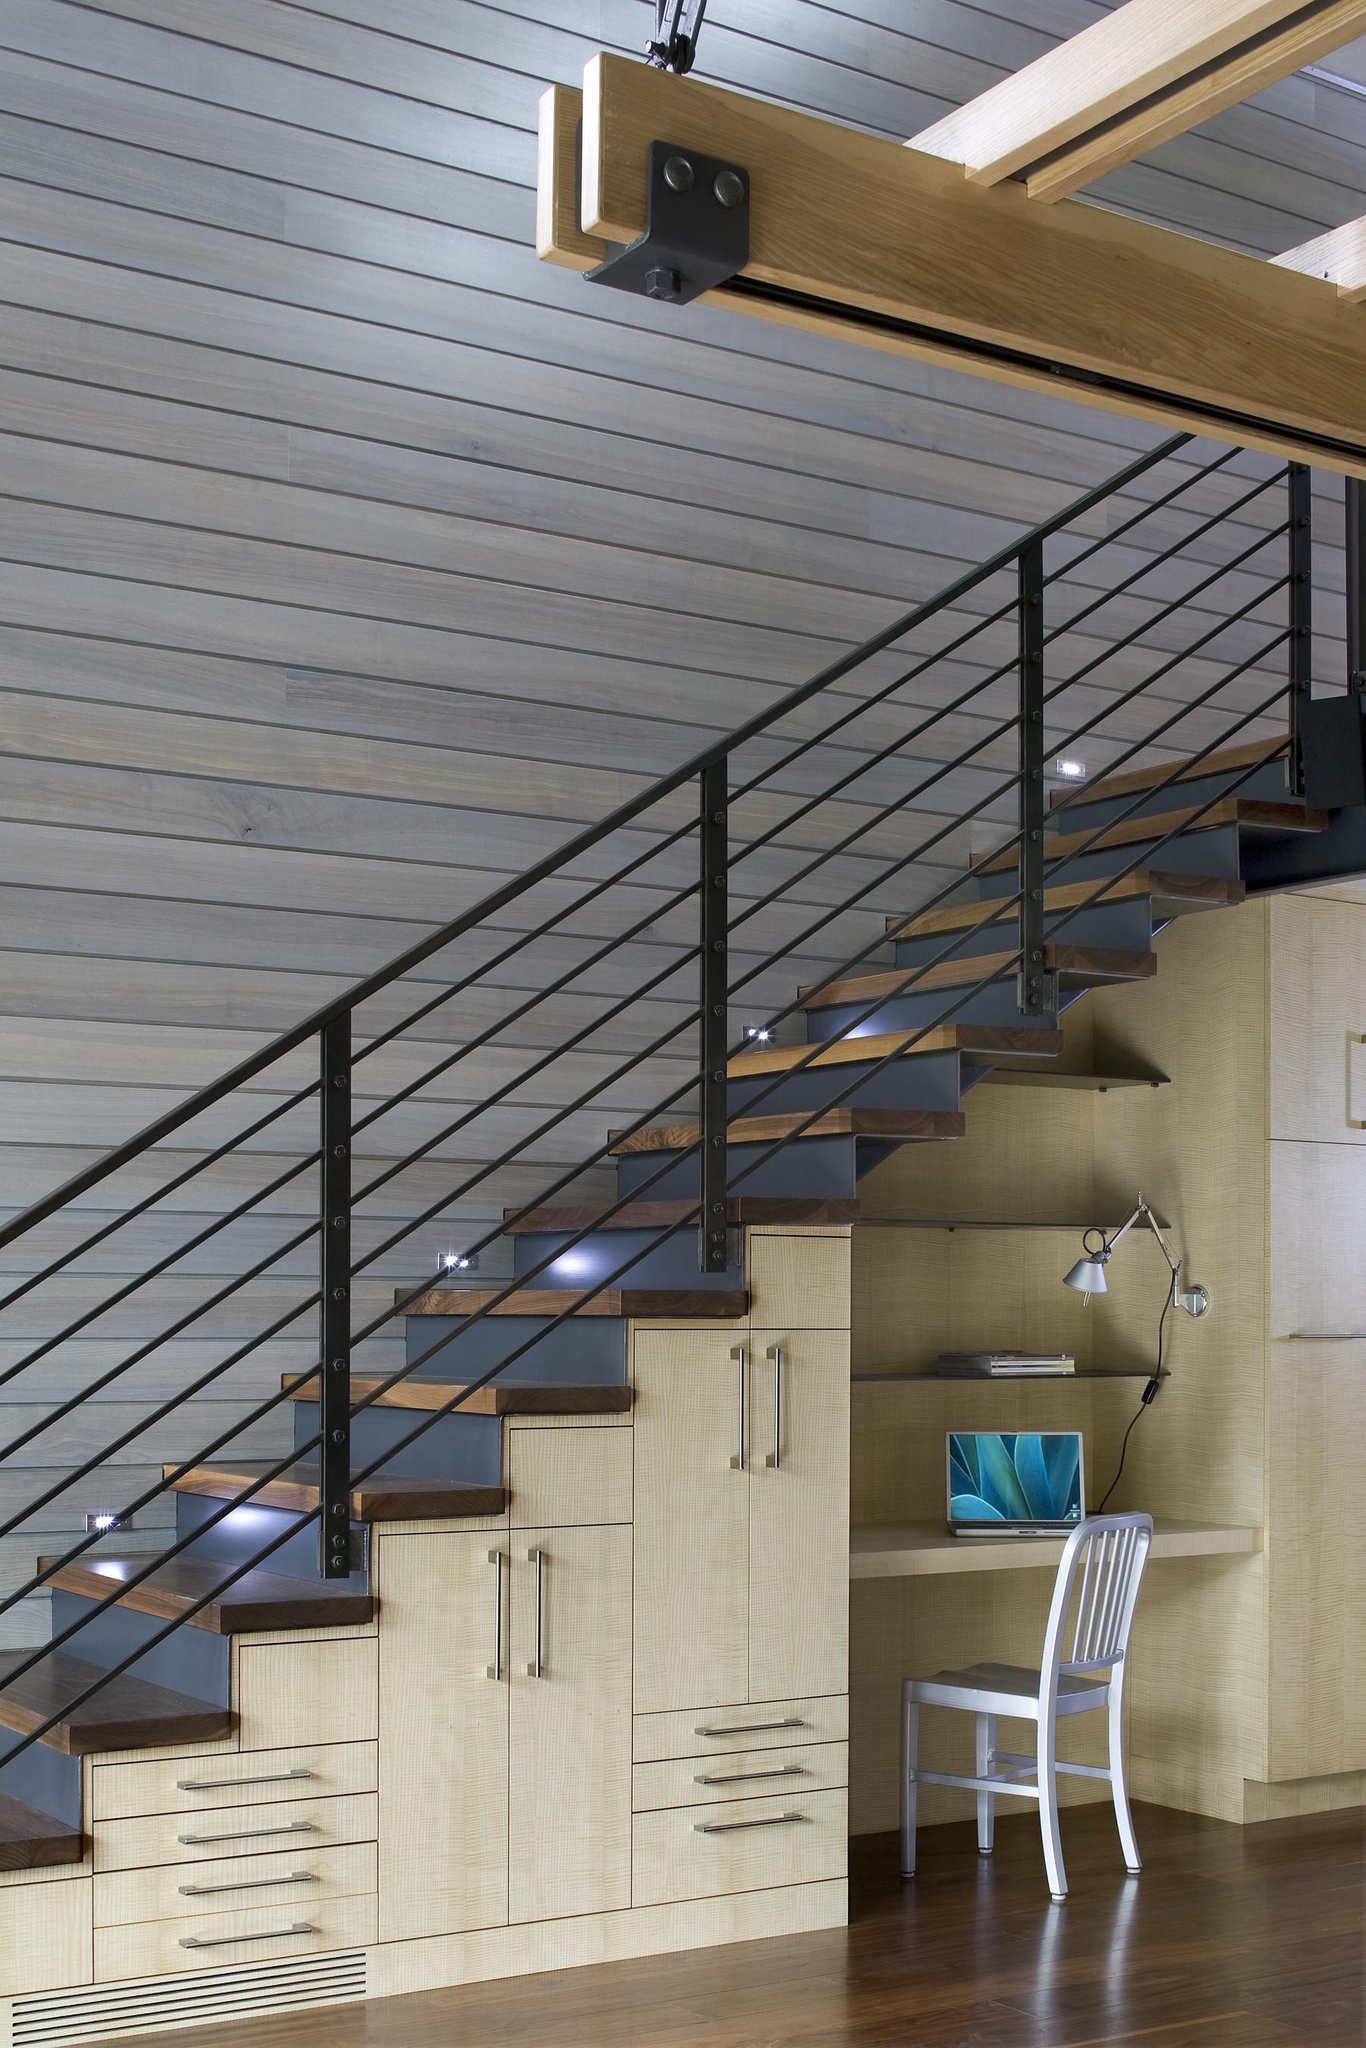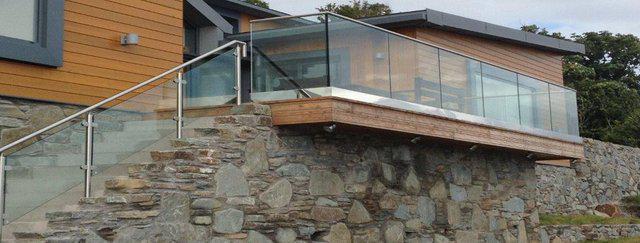The first image is the image on the left, the second image is the image on the right. For the images displayed, is the sentence "One image shows a glass-paneled balcony with a corner on the left, a flat metal rail across the top, and no hinges connecting the balcony panels, and the other image shows a railing with horizontal bars." factually correct? Answer yes or no. Yes. The first image is the image on the left, the second image is the image on the right. Given the left and right images, does the statement "The building in the image on the right is made of bricks." hold true? Answer yes or no. No. 